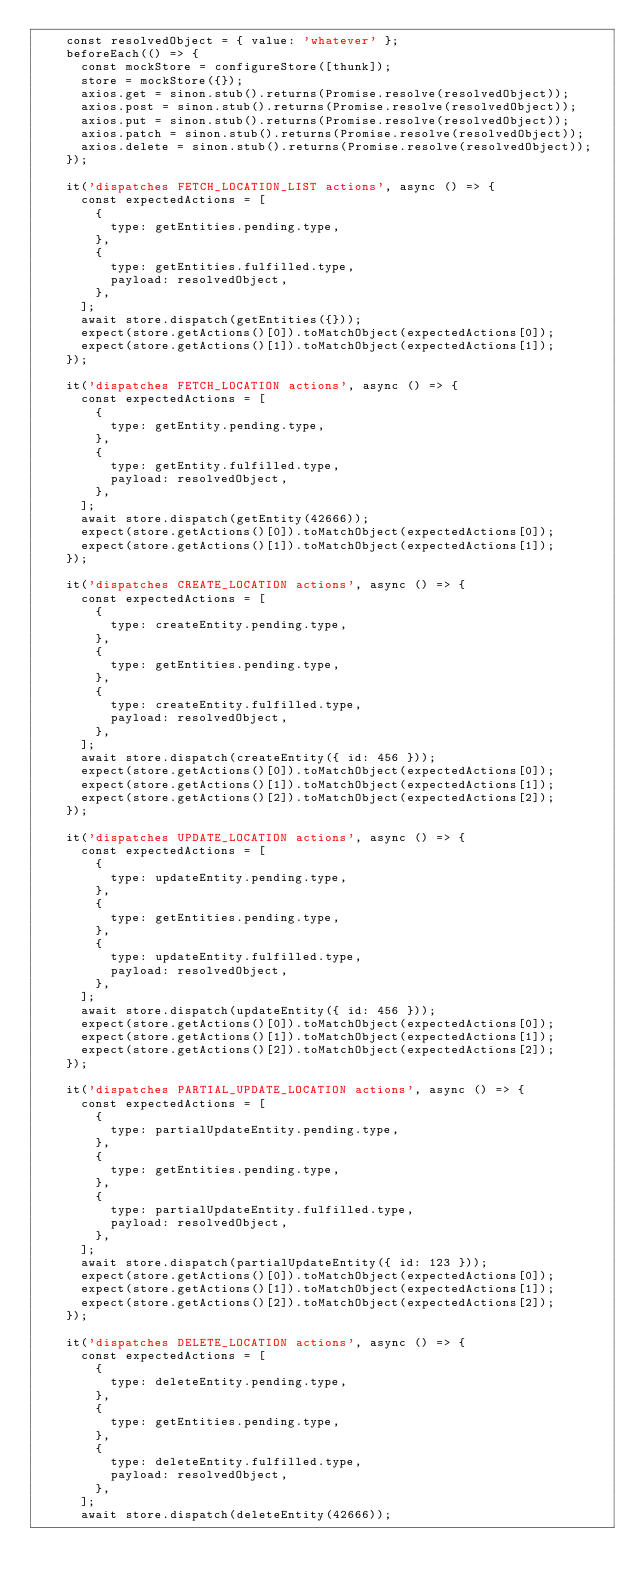Convert code to text. <code><loc_0><loc_0><loc_500><loc_500><_TypeScript_>    const resolvedObject = { value: 'whatever' };
    beforeEach(() => {
      const mockStore = configureStore([thunk]);
      store = mockStore({});
      axios.get = sinon.stub().returns(Promise.resolve(resolvedObject));
      axios.post = sinon.stub().returns(Promise.resolve(resolvedObject));
      axios.put = sinon.stub().returns(Promise.resolve(resolvedObject));
      axios.patch = sinon.stub().returns(Promise.resolve(resolvedObject));
      axios.delete = sinon.stub().returns(Promise.resolve(resolvedObject));
    });

    it('dispatches FETCH_LOCATION_LIST actions', async () => {
      const expectedActions = [
        {
          type: getEntities.pending.type,
        },
        {
          type: getEntities.fulfilled.type,
          payload: resolvedObject,
        },
      ];
      await store.dispatch(getEntities({}));
      expect(store.getActions()[0]).toMatchObject(expectedActions[0]);
      expect(store.getActions()[1]).toMatchObject(expectedActions[1]);
    });

    it('dispatches FETCH_LOCATION actions', async () => {
      const expectedActions = [
        {
          type: getEntity.pending.type,
        },
        {
          type: getEntity.fulfilled.type,
          payload: resolvedObject,
        },
      ];
      await store.dispatch(getEntity(42666));
      expect(store.getActions()[0]).toMatchObject(expectedActions[0]);
      expect(store.getActions()[1]).toMatchObject(expectedActions[1]);
    });

    it('dispatches CREATE_LOCATION actions', async () => {
      const expectedActions = [
        {
          type: createEntity.pending.type,
        },
        {
          type: getEntities.pending.type,
        },
        {
          type: createEntity.fulfilled.type,
          payload: resolvedObject,
        },
      ];
      await store.dispatch(createEntity({ id: 456 }));
      expect(store.getActions()[0]).toMatchObject(expectedActions[0]);
      expect(store.getActions()[1]).toMatchObject(expectedActions[1]);
      expect(store.getActions()[2]).toMatchObject(expectedActions[2]);
    });

    it('dispatches UPDATE_LOCATION actions', async () => {
      const expectedActions = [
        {
          type: updateEntity.pending.type,
        },
        {
          type: getEntities.pending.type,
        },
        {
          type: updateEntity.fulfilled.type,
          payload: resolvedObject,
        },
      ];
      await store.dispatch(updateEntity({ id: 456 }));
      expect(store.getActions()[0]).toMatchObject(expectedActions[0]);
      expect(store.getActions()[1]).toMatchObject(expectedActions[1]);
      expect(store.getActions()[2]).toMatchObject(expectedActions[2]);
    });

    it('dispatches PARTIAL_UPDATE_LOCATION actions', async () => {
      const expectedActions = [
        {
          type: partialUpdateEntity.pending.type,
        },
        {
          type: getEntities.pending.type,
        },
        {
          type: partialUpdateEntity.fulfilled.type,
          payload: resolvedObject,
        },
      ];
      await store.dispatch(partialUpdateEntity({ id: 123 }));
      expect(store.getActions()[0]).toMatchObject(expectedActions[0]);
      expect(store.getActions()[1]).toMatchObject(expectedActions[1]);
      expect(store.getActions()[2]).toMatchObject(expectedActions[2]);
    });

    it('dispatches DELETE_LOCATION actions', async () => {
      const expectedActions = [
        {
          type: deleteEntity.pending.type,
        },
        {
          type: getEntities.pending.type,
        },
        {
          type: deleteEntity.fulfilled.type,
          payload: resolvedObject,
        },
      ];
      await store.dispatch(deleteEntity(42666));</code> 